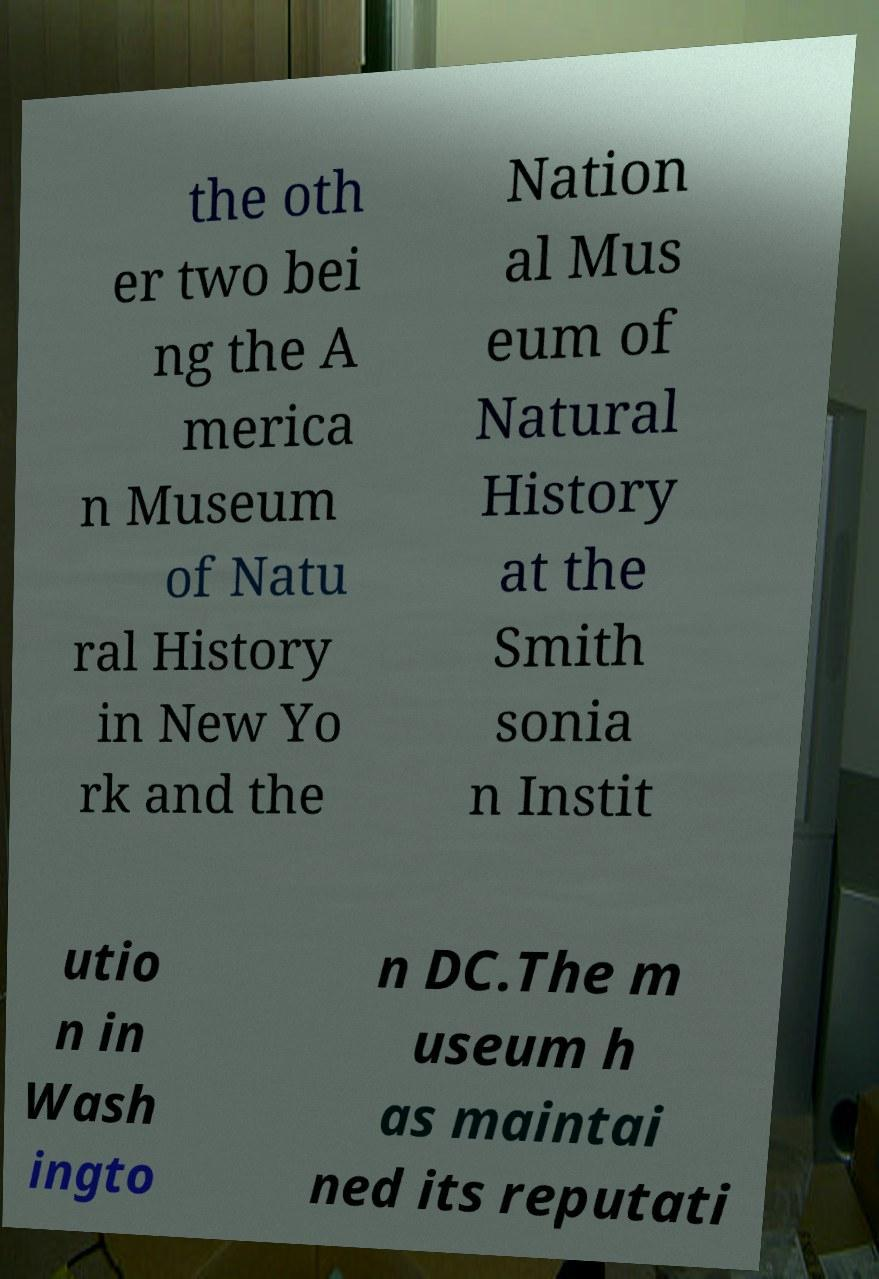Can you read and provide the text displayed in the image?This photo seems to have some interesting text. Can you extract and type it out for me? the oth er two bei ng the A merica n Museum of Natu ral History in New Yo rk and the Nation al Mus eum of Natural History at the Smith sonia n Instit utio n in Wash ingto n DC.The m useum h as maintai ned its reputati 